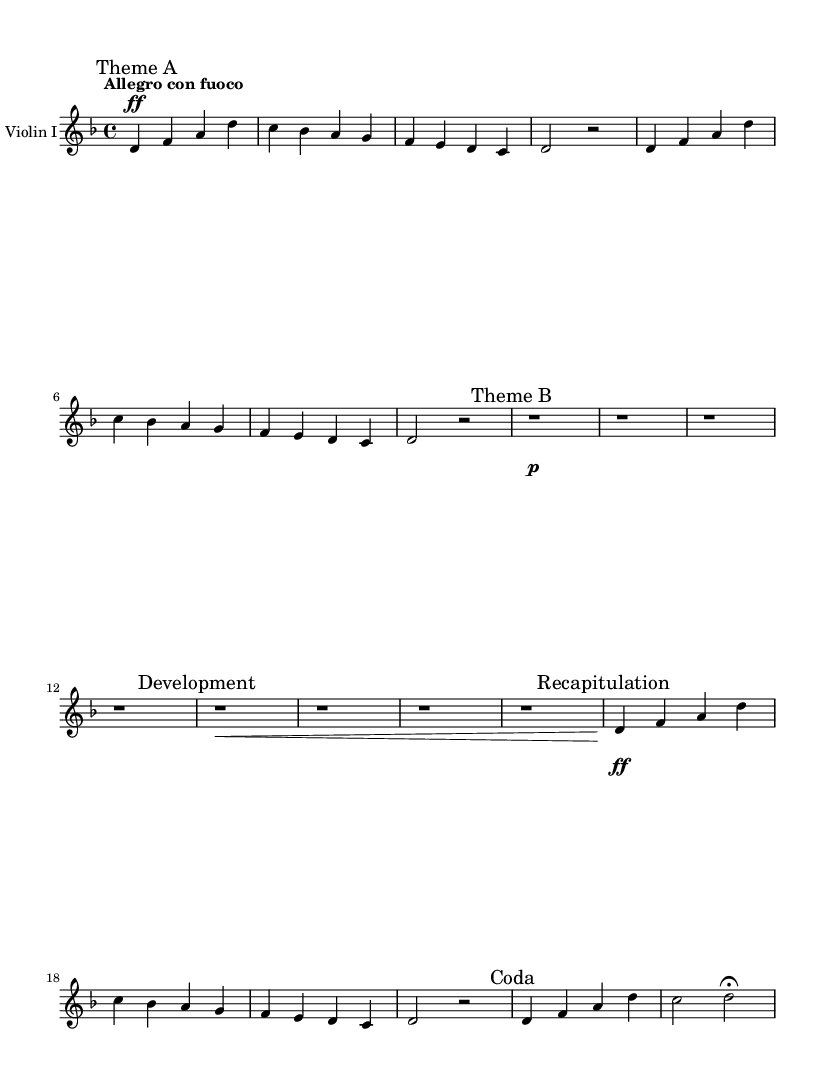What is the key signature of this music? The key signature is two flats, which indicates D minor. The absence of sharps or additional flats helps identify it clearly.
Answer: D minor What is the time signature of this piece? The time signature at the beginning of the score indicates there are four beats per measure, which is represented as 4/4.
Answer: 4/4 What is the tempo marking for this piece? The tempo marking states "Allegro con fuoco," which means to play in a lively and fiery manner. This can be found at the beginning of the piece.
Answer: Allegro con fuoco How many main sections are identified in the score? The score clearly labels five sections: Theme A, Theme B, Development, Recapitulation, and Coda. Each section is marked accordingly, providing a structural overview.
Answer: Five What dynamic marking is indicated for Theme A? The dynamic marking shows "ff," indicating a forte or loud emphasis for Theme A. This is depicted just before the music enters the Theme A section.
Answer: Forte Which section contains a rest before continuation? In the score, the "Development" section has multiple measures with "r1" which indicates a whole rest, allowing pauses before the music resumes. This pause is highlighted in that specific section.
Answer: Development What is the last note value in the score's "Coda" section? The last note in the Coda section is marked with a fermata, which signifies that it should be held longer than its written value. This notation is present at the end of the Coda, indicating its significance.
Answer: Fermata 